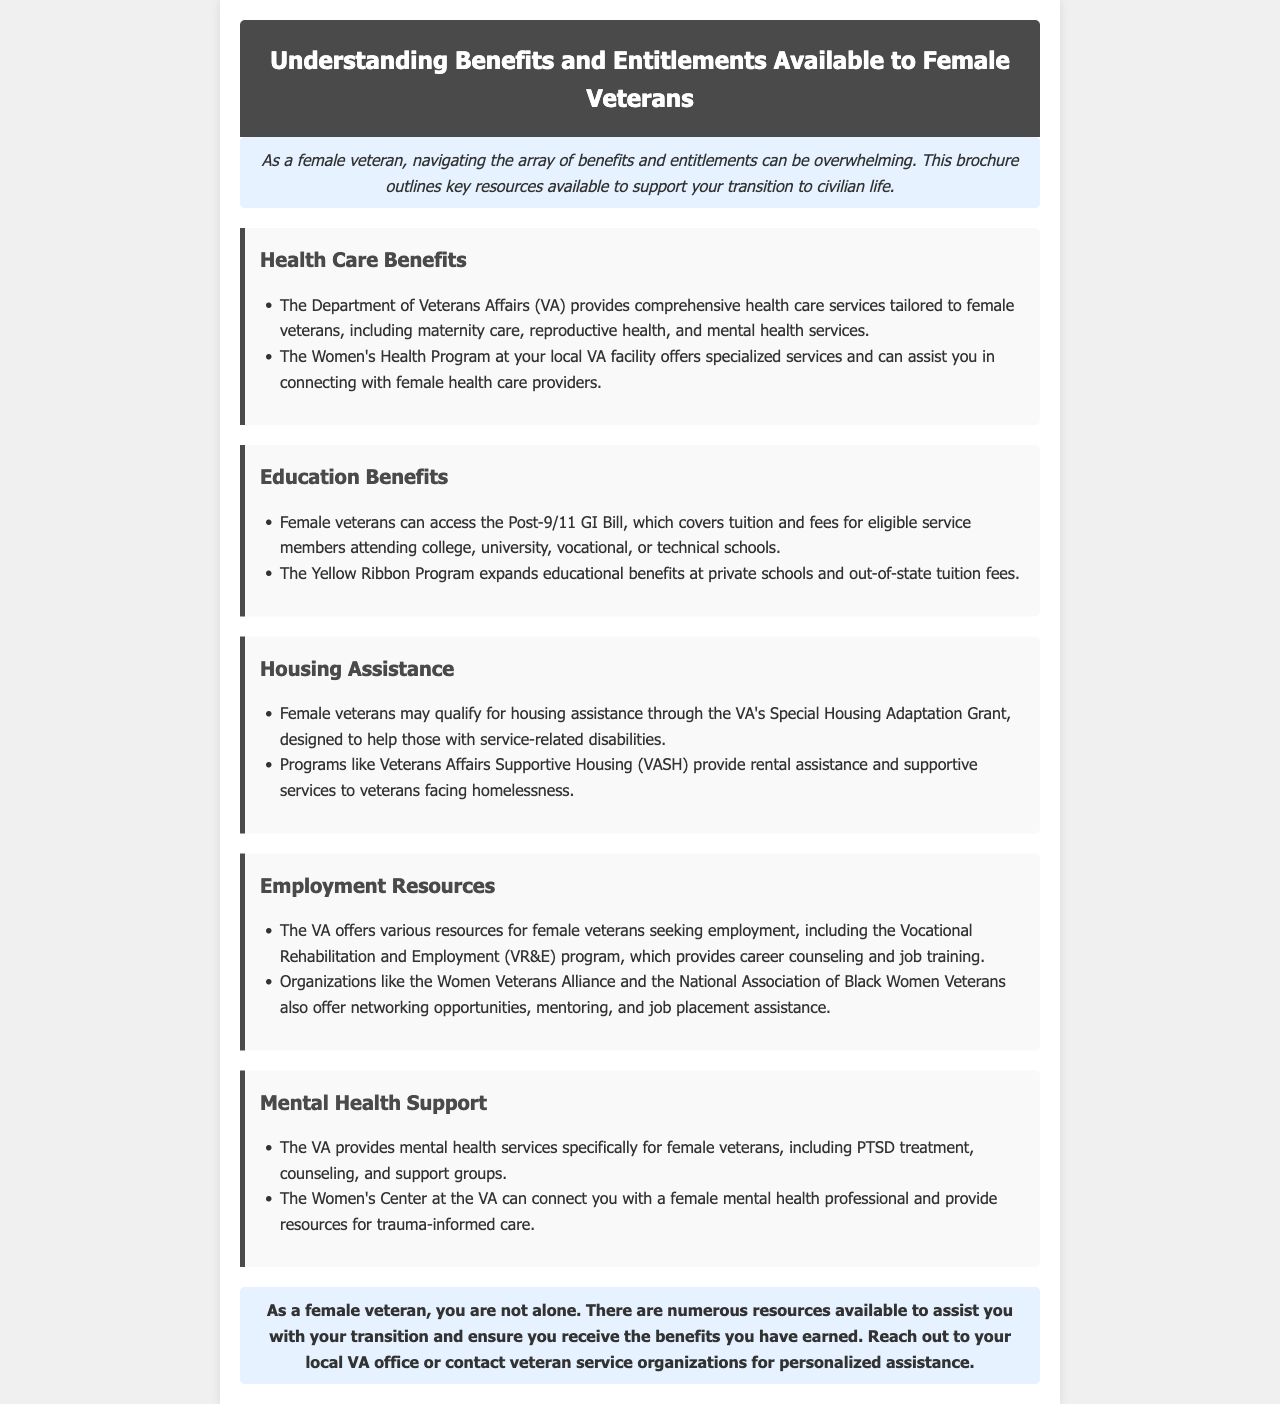What health care services are tailored to female veterans? The document lists comprehensive health care services including maternity care, reproductive health, and mental health services as tailored to female veterans.
Answer: Maternity care, reproductive health, mental health services What program covers tuition and fees for female veterans attending college? The Post-9/11 GI Bill is specifically mentioned in the document as a program that covers tuition and fees for eligible service members attending college.
Answer: Post-9/11 GI Bill Which grant assists female veterans with service-related disabilities? The document mentions the Special Housing Adaptation Grant as a program designed to help those with service-related disabilities.
Answer: Special Housing Adaptation Grant What organization provides networking opportunities for female veterans? The Women Veterans Alliance is cited in the document as an organization offering networking opportunities, mentoring, and job placement assistance.
Answer: Women Veterans Alliance What type of treatment does the VA provide specifically for female veterans? The document states that the VA provides mental health services specifically for female veterans, including PTSD treatment.
Answer: PTSD treatment What is the main purpose of the brochure? The brochure outlines key resources available to support the transition of female veterans to civilian life.
Answer: Support transition to civilian life Which VA program assists with career counseling and job training? The Vocational Rehabilitation and Employment (VR&E) program is described as providing career counseling and job training in the document.
Answer: Vocational Rehabilitation and Employment (VR&E) How does the Women's Center at the VA support female veterans? The Women's Center at the VA can connect female veterans with a female mental health professional and provide resources for trauma-informed care.
Answer: Connect with a female mental health professional What can female veterans access for rental assistance? The Veterans Affairs Supportive Housing (VASH) program provides rental assistance and supportive services to veterans facing homelessness.
Answer: Veterans Affairs Supportive Housing (VASH) What should female veterans do for personalized assistance with their benefits? The document encourages female veterans to reach out to their local VA office or contact veteran service organizations for personalized assistance.
Answer: Reach out to local VA office 